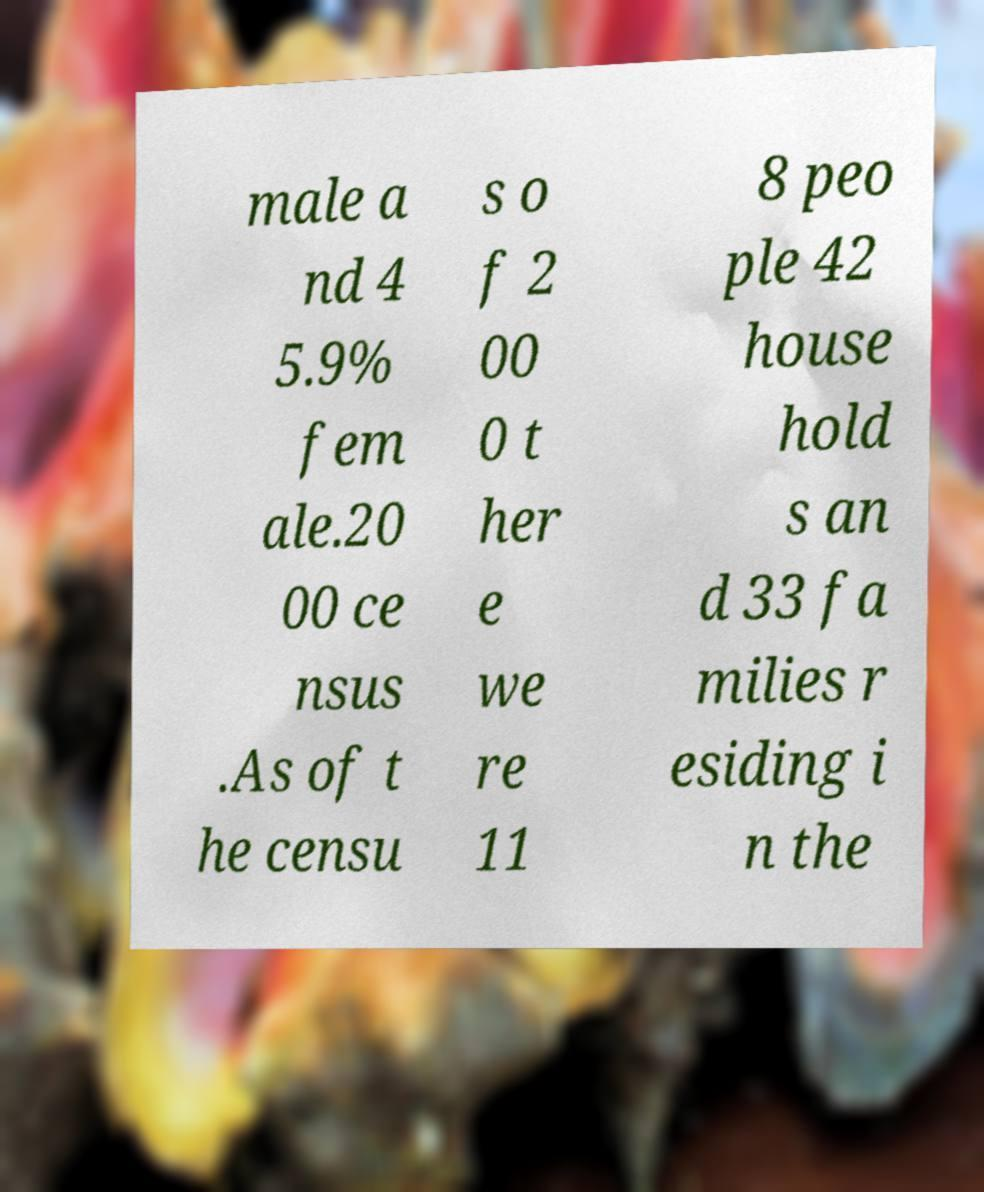Can you read and provide the text displayed in the image?This photo seems to have some interesting text. Can you extract and type it out for me? male a nd 4 5.9% fem ale.20 00 ce nsus .As of t he censu s o f 2 00 0 t her e we re 11 8 peo ple 42 house hold s an d 33 fa milies r esiding i n the 